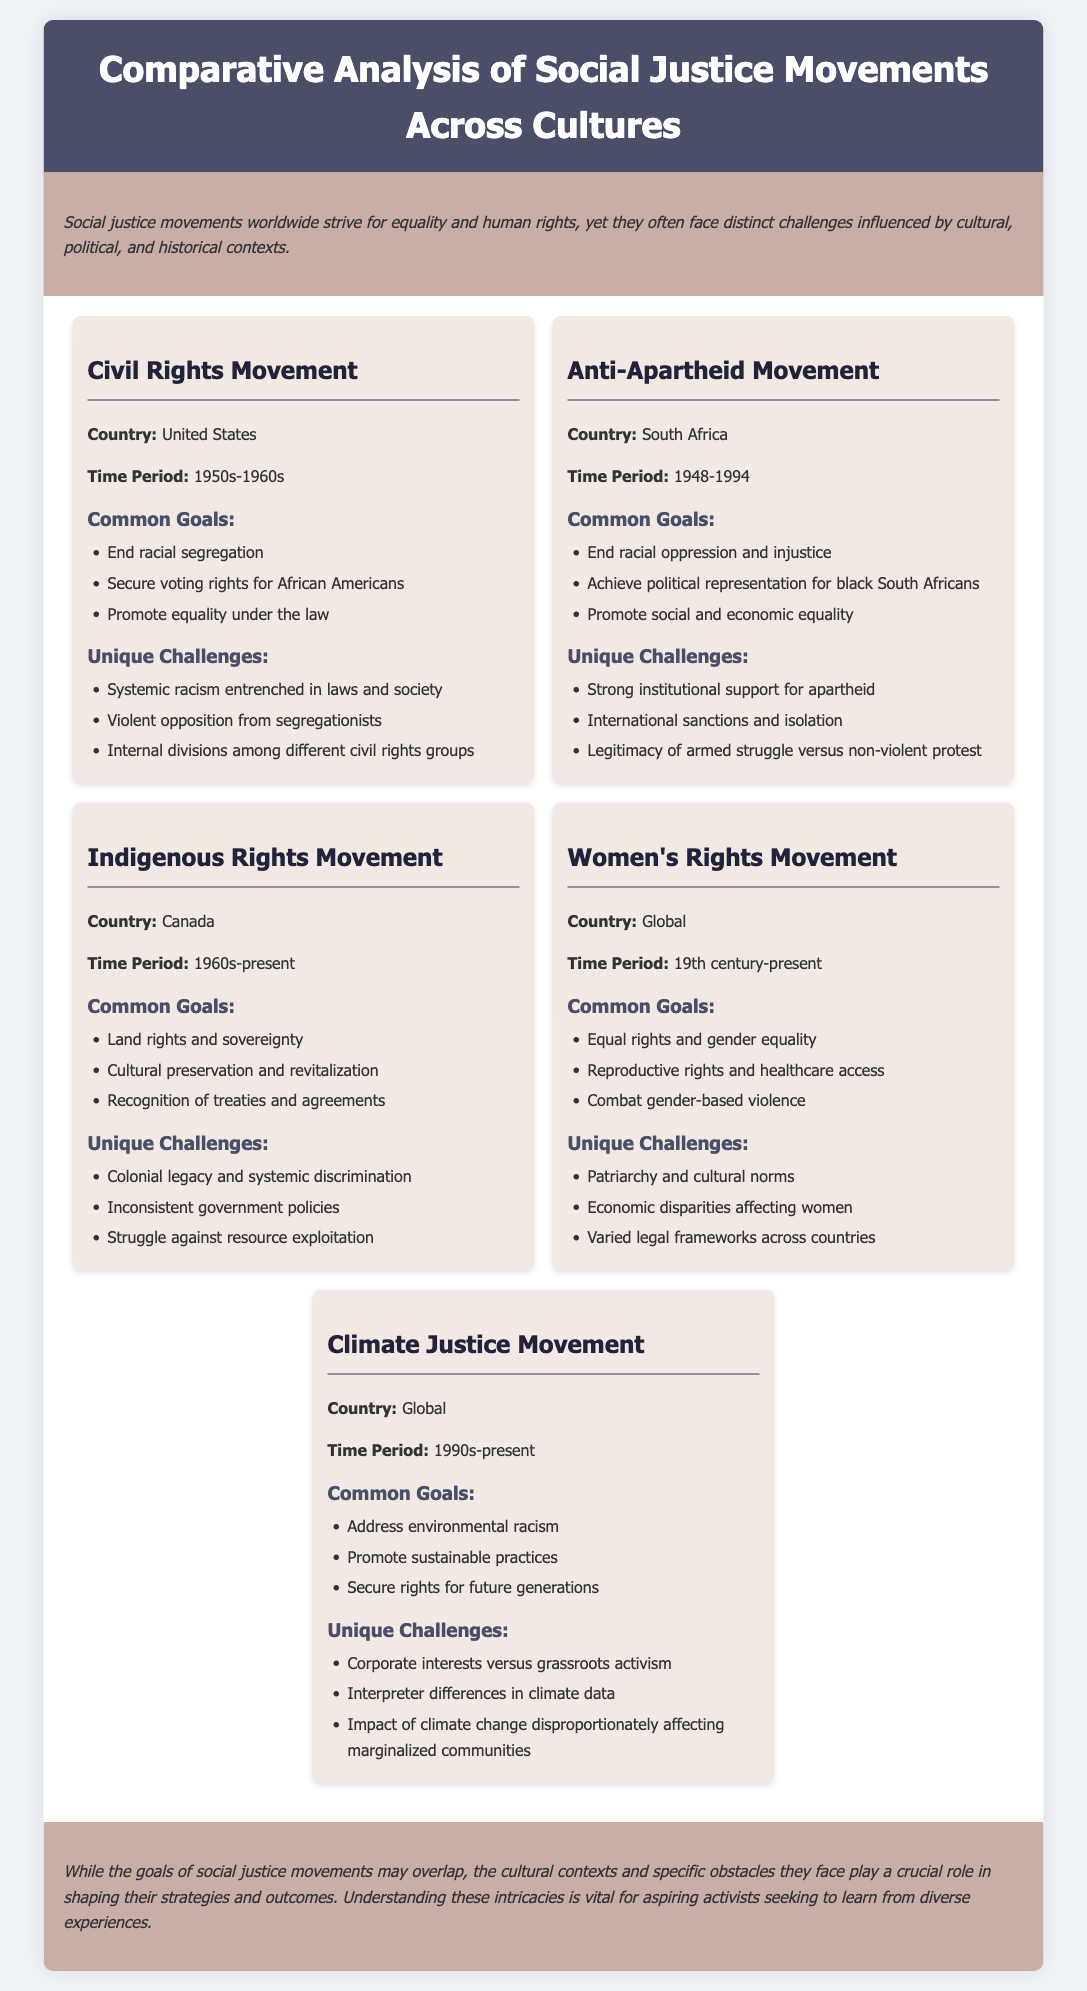What is the country associated with the Civil Rights Movement? The document specifically mentions the United States as the country for the Civil Rights Movement.
Answer: United States What time period did the Anti-Apartheid Movement occur? The document states the time period for the Anti-Apartheid Movement was 1948-1994.
Answer: 1948-1994 What is one common goal of the Women's Rights Movement? The document lists several common goals for the Women's Rights Movement, including equal rights and gender equality.
Answer: Equal rights and gender equality What is a unique challenge faced by the Indigenous Rights Movement? According to the document, one unique challenge is the colonial legacy and systemic discrimination.
Answer: Colonial legacy and systemic discrimination What is a common goal of the Climate Justice Movement? The document indicates that addressing environmental racism is one of the common goals of the Climate Justice Movement.
Answer: Address environmental racism What do social justice movements worldwide strive for? The document states that social justice movements worldwide strive for equality and human rights.
Answer: Equality and human rights How do the challenges faced by different movements vary? The document mentions that cultural contexts and specific obstacles play a crucial role in shaping strategies and outcomes of the movements.
Answer: Cultural contexts and specific obstacles What is the overarching theme of the document? The document suggests that while goals may overlap, understanding cultural nuances is crucial for activists.
Answer: Comparative analysis of social justice movements across cultures What time period does the Women's Rights Movement encompass? The document specifies that the Women's Rights Movement spans from the 19th century to the present.
Answer: 19th century-present 